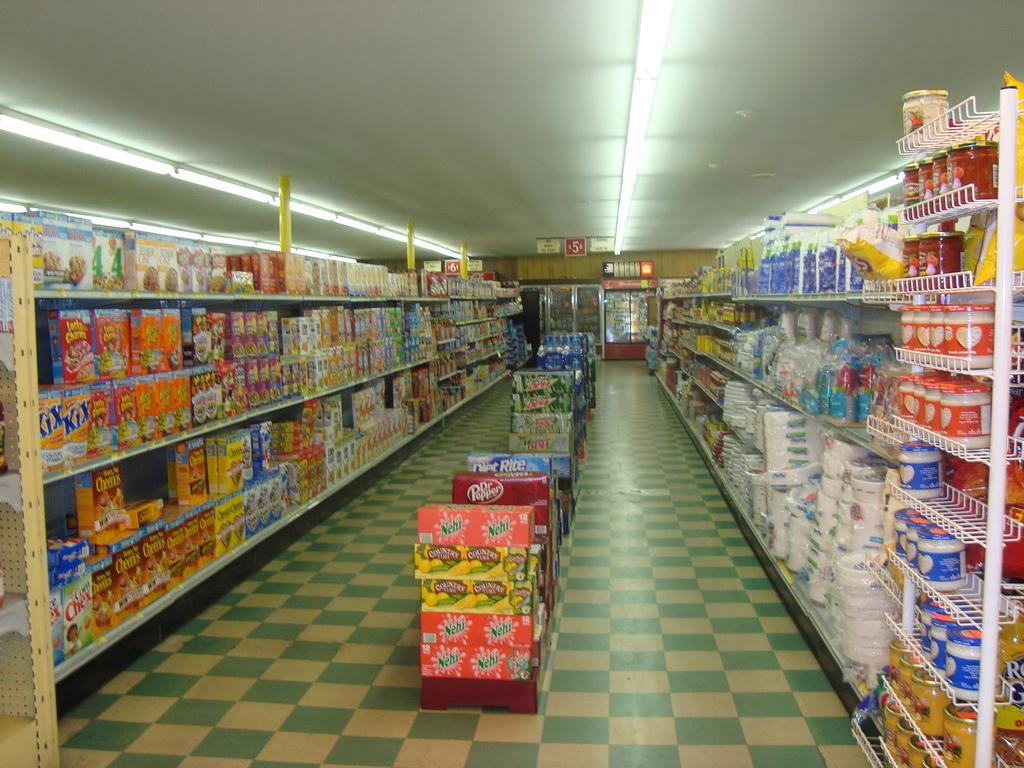<image>
Relay a brief, clear account of the picture shown. The box of Kix cereal is at the very end of the left aisle. 